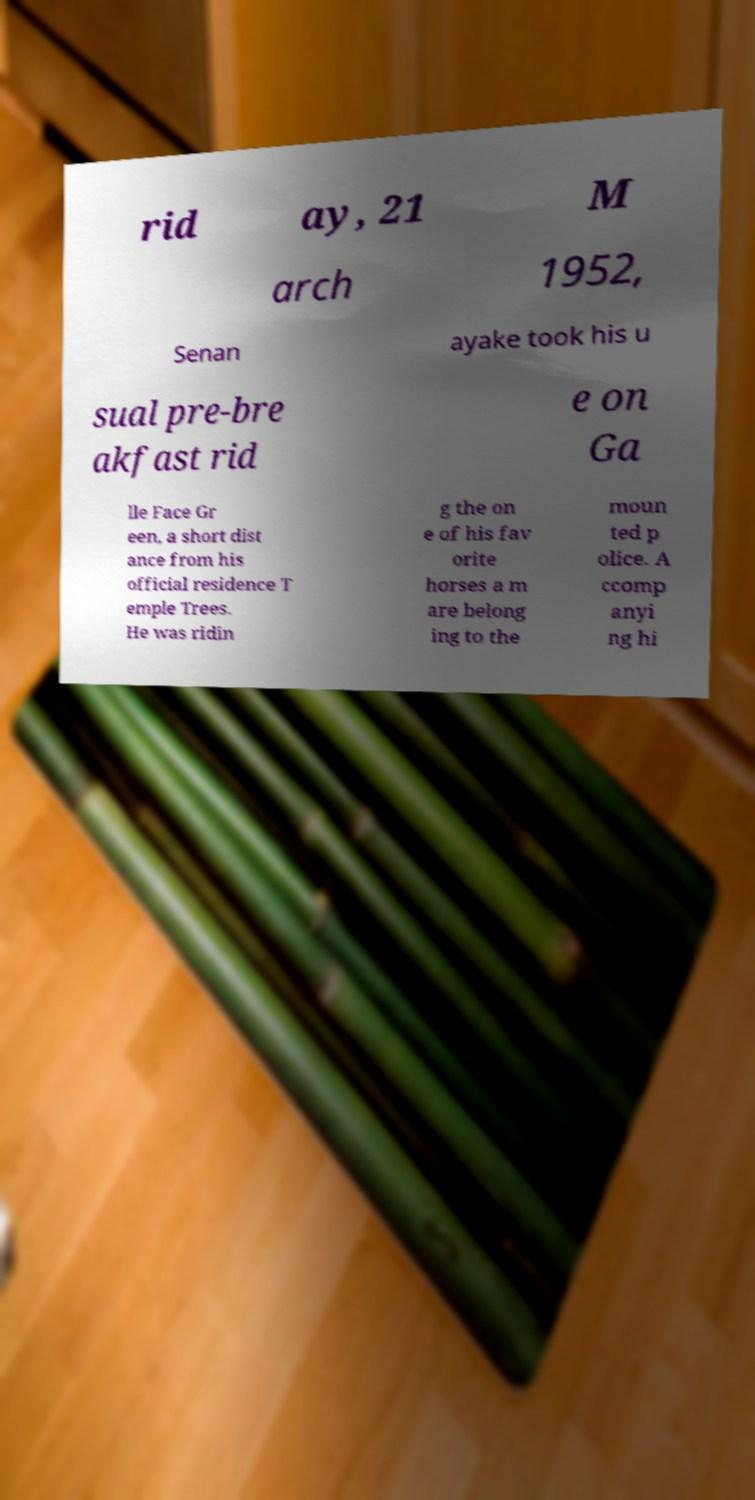What messages or text are displayed in this image? I need them in a readable, typed format. rid ay, 21 M arch 1952, Senan ayake took his u sual pre-bre akfast rid e on Ga lle Face Gr een, a short dist ance from his official residence T emple Trees. He was ridin g the on e of his fav orite horses a m are belong ing to the moun ted p olice. A ccomp anyi ng hi 